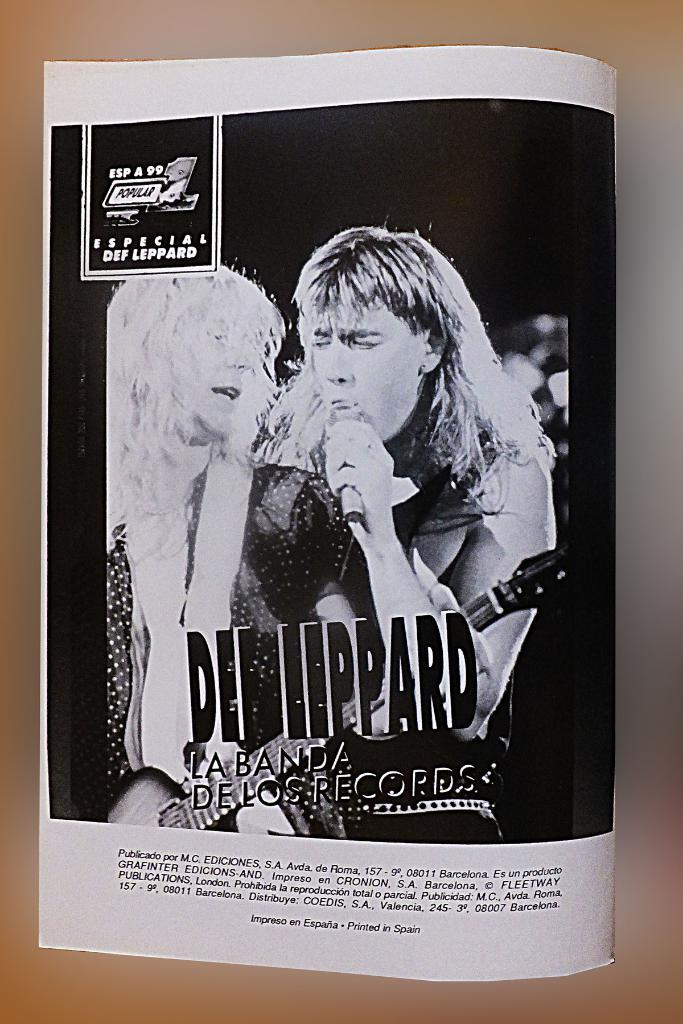Provide a one-sentence caption for the provided image. A Spanish language article takes a look at heavy metal icons Def Leppard. 